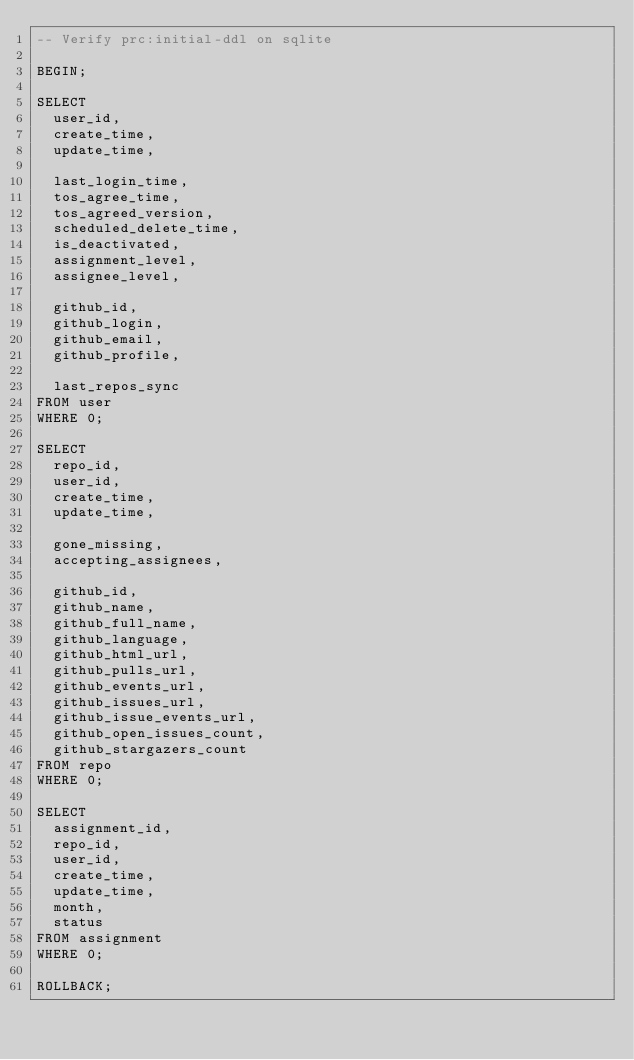Convert code to text. <code><loc_0><loc_0><loc_500><loc_500><_SQL_>-- Verify prc:initial-ddl on sqlite

BEGIN;

SELECT
  user_id,
  create_time,
  update_time,

  last_login_time,
  tos_agree_time,
  tos_agreed_version,
  scheduled_delete_time,
  is_deactivated,
  assignment_level,
  assignee_level,

  github_id,
  github_login,
  github_email,
  github_profile,

  last_repos_sync
FROM user
WHERE 0;

SELECT
  repo_id,
  user_id,
  create_time,
  update_time,

  gone_missing,
  accepting_assignees,

  github_id,
  github_name,
  github_full_name,
  github_language,
  github_html_url,
  github_pulls_url,
  github_events_url,
  github_issues_url,
  github_issue_events_url,
  github_open_issues_count,
  github_stargazers_count
FROM repo
WHERE 0;

SELECT
  assignment_id,
  repo_id,
  user_id,
  create_time,
  update_time,
  month,
  status
FROM assignment
WHERE 0;

ROLLBACK;
</code> 